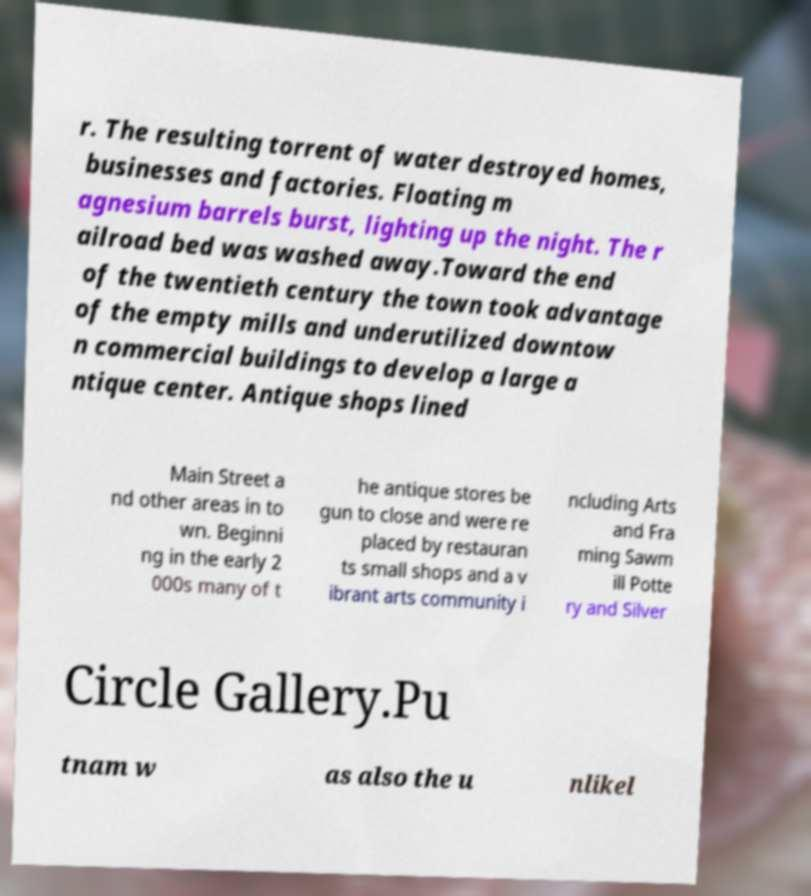Please identify and transcribe the text found in this image. r. The resulting torrent of water destroyed homes, businesses and factories. Floating m agnesium barrels burst, lighting up the night. The r ailroad bed was washed away.Toward the end of the twentieth century the town took advantage of the empty mills and underutilized downtow n commercial buildings to develop a large a ntique center. Antique shops lined Main Street a nd other areas in to wn. Beginni ng in the early 2 000s many of t he antique stores be gun to close and were re placed by restauran ts small shops and a v ibrant arts community i ncluding Arts and Fra ming Sawm ill Potte ry and Silver Circle Gallery.Pu tnam w as also the u nlikel 